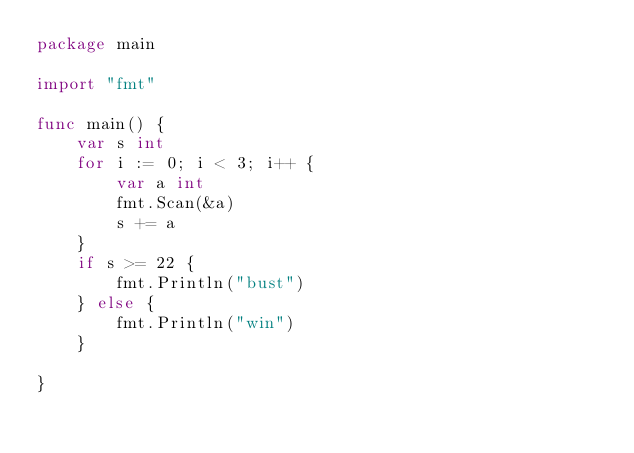Convert code to text. <code><loc_0><loc_0><loc_500><loc_500><_Go_>package main

import "fmt"

func main() {
	var s int
	for i := 0; i < 3; i++ {
		var a int
		fmt.Scan(&a)
		s += a
	}
	if s >= 22 {
		fmt.Println("bust")
	} else {
		fmt.Println("win")
	}

}
</code> 